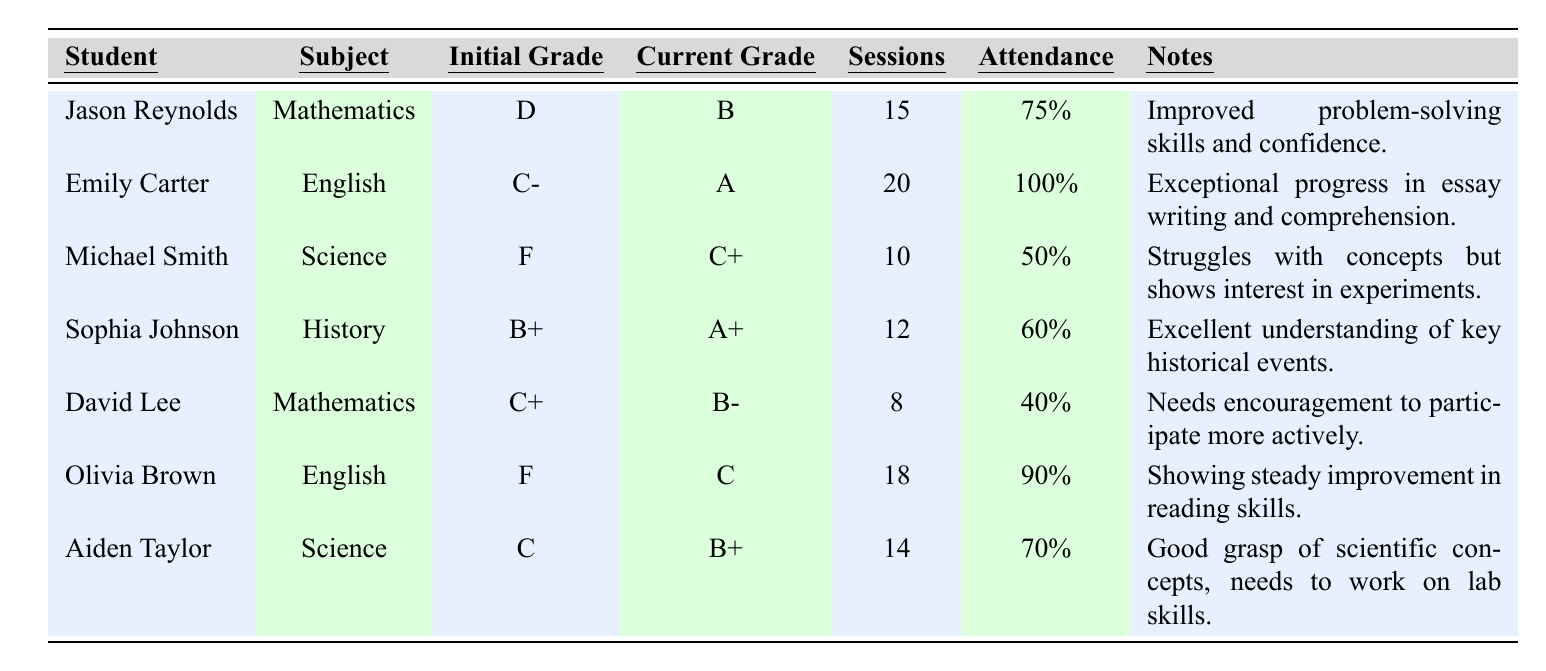What is the initial grade of Jason Reynolds? Look at the row for Jason Reynolds in the table, and check the column labeled "Initial Grade." It indicates that his initial grade was D.
Answer: D How many sessions did Emily Carter attend? Refer to Emily Carter's row and find the column labeled "Sessions." She attended 20 sessions.
Answer: 20 Which student showed the greatest improvement in grades? To determine the greatest improvement, compare the initial and current grades of each student. Emily Carter went from C- to A for a total increase of 3 grades. The grades for all students show this is the largest change.
Answer: Emily Carter What is the attendance rate of Aiden Taylor? In the row for Aiden Taylor, locate the column titled "Attendance." It shows an attendance rate of 70%.
Answer: 70% How many students improved their grades to at least a B? Analyze the "Current Grade" column to find out how many students achieved a grade of B or higher. Jason Reynolds, Emily Carter, Sophia Johnson, and Aiden Taylor all achieved at least a B, totaling four students.
Answer: 4 What is the average attendance rate of all students? Add the attendance rates together: 75% + 100% + 50% + 60% + 40% + 90% + 70% = 485%. There are 7 students, so divide 485% by 7, which gives an average attendance rate of approximately 69.29%.
Answer: 69.29% Did any student have a current grade of F? Check the "Current Grade" column for any instance of F. It shows that Michael Smith and Olivia Brown have not improved enough and their current grades remain below C.
Answer: Yes Which subject had the highest attendance rate among the students? Review the attendance rates for each subject by looking at the sessions attended and attendance rates. English (Emily Carter 100% and Olivia Brown 90%) has the highest attendance rates. The average for English is 95%, while Mathematics averages 57.5%, and Science averages 60% making English the highest.
Answer: English How many students attended fewer than 15 sessions? Review each student's sessions attended count and identify those below 15. Jason Reynolds (15), Michael Smith (10), David Lee (8) and Sophia Johnson (12) attended fewer than 15 sessions totaling four students.
Answer: 4 Which student in Science showed the least improvement? Analyze the grades in the Science subject: Michael Smith changed from F to C+, while Aiden Taylor improved from C to B+. Michael Smith’s change represents a lesser improvement compared to Aiden Taylor.
Answer: Michael Smith 